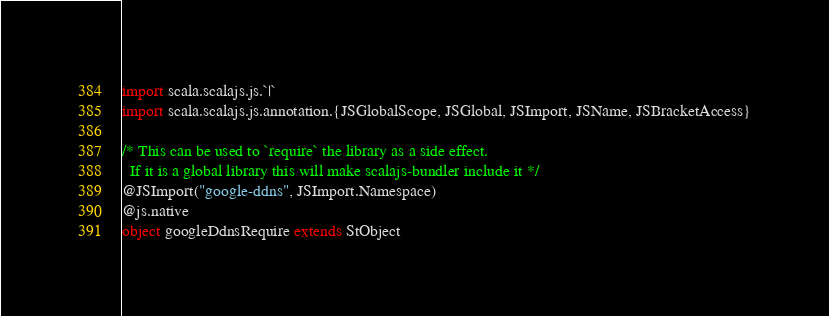<code> <loc_0><loc_0><loc_500><loc_500><_Scala_>import scala.scalajs.js.`|`
import scala.scalajs.js.annotation.{JSGlobalScope, JSGlobal, JSImport, JSName, JSBracketAccess}

/* This can be used to `require` the library as a side effect.
  If it is a global library this will make scalajs-bundler include it */
@JSImport("google-ddns", JSImport.Namespace)
@js.native
object googleDdnsRequire extends StObject
</code> 